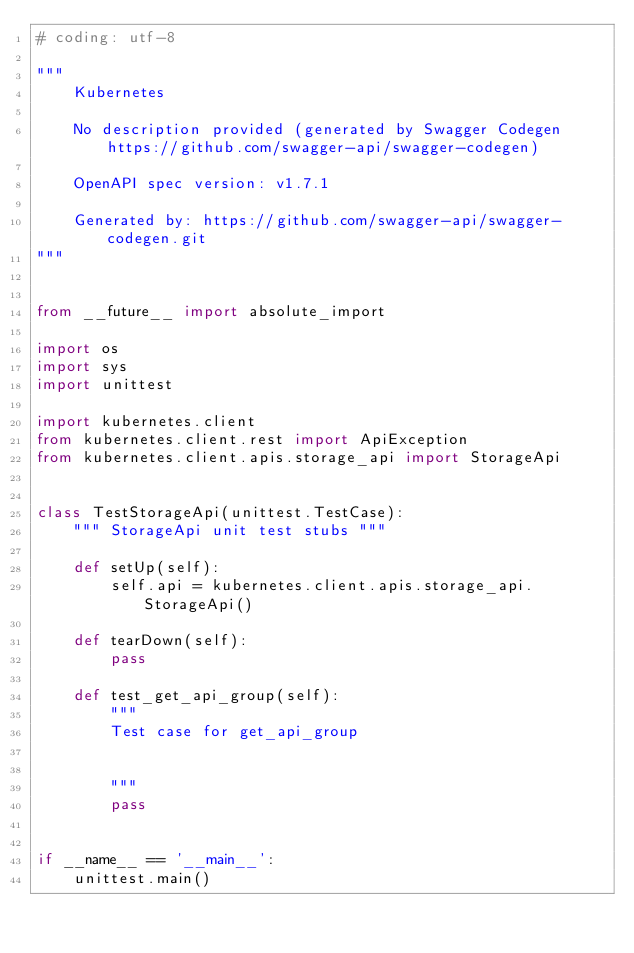Convert code to text. <code><loc_0><loc_0><loc_500><loc_500><_Python_># coding: utf-8

"""
    Kubernetes

    No description provided (generated by Swagger Codegen https://github.com/swagger-api/swagger-codegen)

    OpenAPI spec version: v1.7.1
    
    Generated by: https://github.com/swagger-api/swagger-codegen.git
"""


from __future__ import absolute_import

import os
import sys
import unittest

import kubernetes.client
from kubernetes.client.rest import ApiException
from kubernetes.client.apis.storage_api import StorageApi


class TestStorageApi(unittest.TestCase):
    """ StorageApi unit test stubs """

    def setUp(self):
        self.api = kubernetes.client.apis.storage_api.StorageApi()

    def tearDown(self):
        pass

    def test_get_api_group(self):
        """
        Test case for get_api_group

        
        """
        pass


if __name__ == '__main__':
    unittest.main()
</code> 